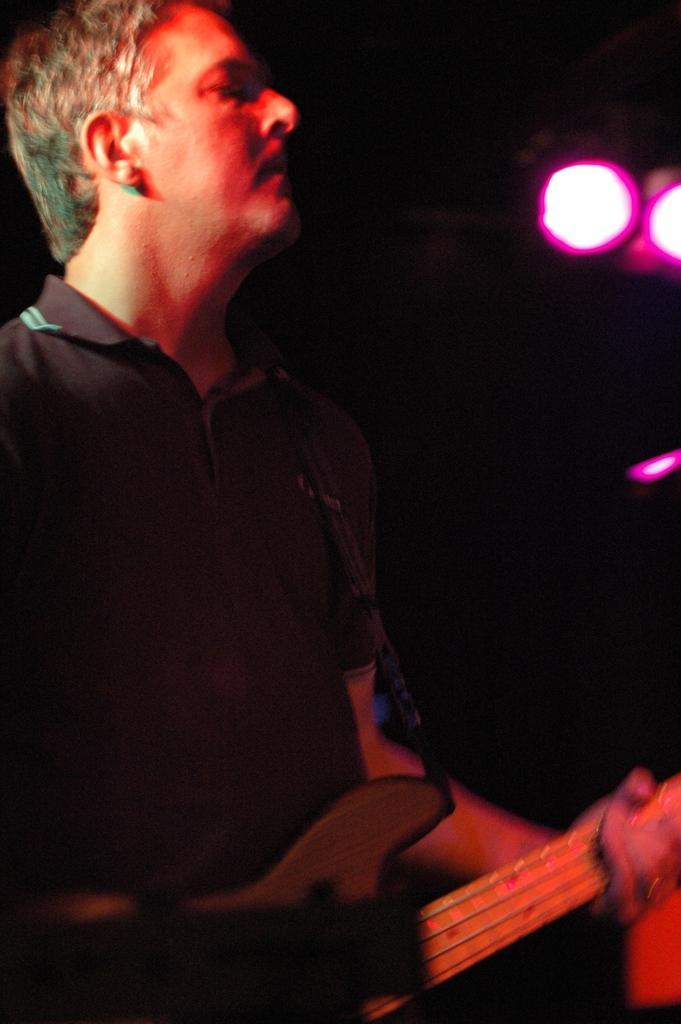How would you summarize this image in a sentence or two? In this image there is a man who is playing the guitar with his hand. At the top there are lights. 